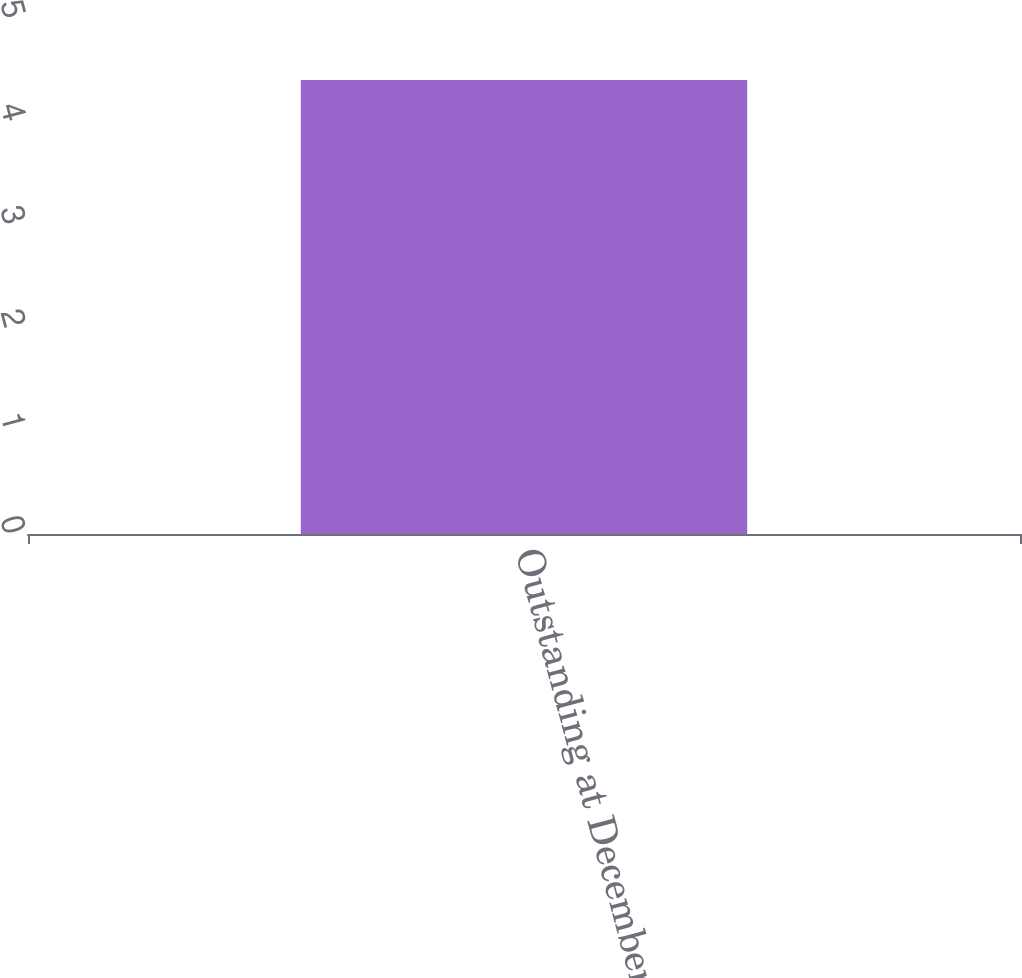Convert chart to OTSL. <chart><loc_0><loc_0><loc_500><loc_500><bar_chart><fcel>Outstanding at December 31<nl><fcel>4.4<nl></chart> 